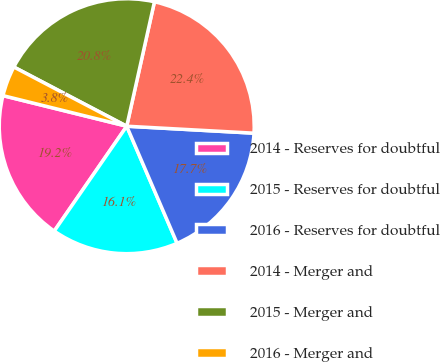Convert chart. <chart><loc_0><loc_0><loc_500><loc_500><pie_chart><fcel>2014 - Reserves for doubtful<fcel>2015 - Reserves for doubtful<fcel>2016 - Reserves for doubtful<fcel>2014 - Merger and<fcel>2015 - Merger and<fcel>2016 - Merger and<nl><fcel>19.23%<fcel>16.09%<fcel>17.66%<fcel>22.38%<fcel>20.8%<fcel>3.83%<nl></chart> 